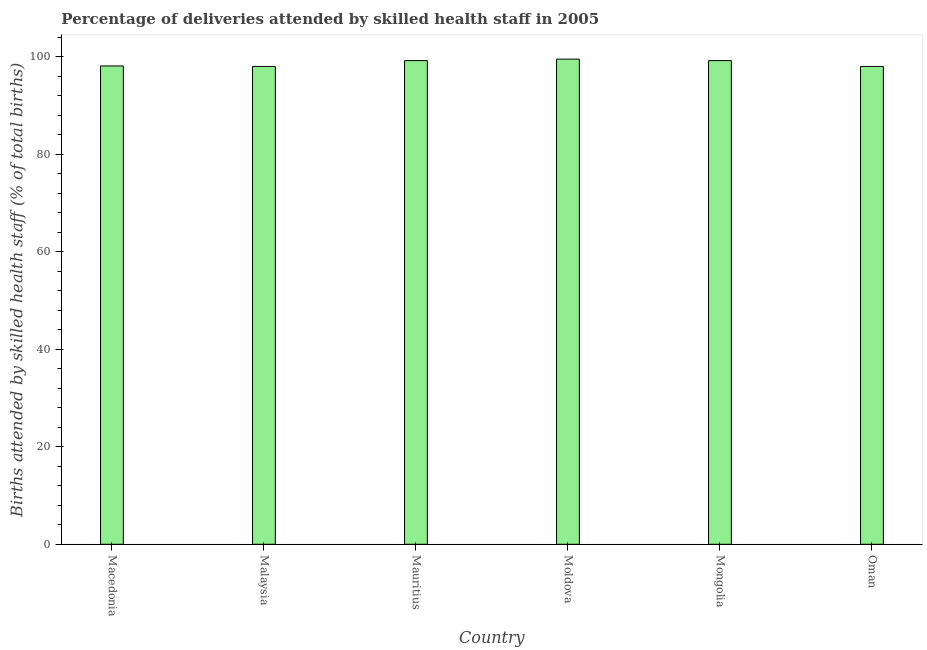Does the graph contain grids?
Offer a terse response. No. What is the title of the graph?
Keep it short and to the point. Percentage of deliveries attended by skilled health staff in 2005. What is the label or title of the X-axis?
Your answer should be compact. Country. What is the label or title of the Y-axis?
Provide a short and direct response. Births attended by skilled health staff (% of total births). What is the number of births attended by skilled health staff in Malaysia?
Give a very brief answer. 98. Across all countries, what is the maximum number of births attended by skilled health staff?
Make the answer very short. 99.5. Across all countries, what is the minimum number of births attended by skilled health staff?
Ensure brevity in your answer.  98. In which country was the number of births attended by skilled health staff maximum?
Give a very brief answer. Moldova. In which country was the number of births attended by skilled health staff minimum?
Keep it short and to the point. Malaysia. What is the sum of the number of births attended by skilled health staff?
Provide a succinct answer. 592. What is the average number of births attended by skilled health staff per country?
Provide a short and direct response. 98.67. What is the median number of births attended by skilled health staff?
Give a very brief answer. 98.65. In how many countries, is the number of births attended by skilled health staff greater than 72 %?
Make the answer very short. 6. What is the ratio of the number of births attended by skilled health staff in Mauritius to that in Oman?
Make the answer very short. 1.01. Is the number of births attended by skilled health staff in Macedonia less than that in Malaysia?
Give a very brief answer. No. Is the difference between the number of births attended by skilled health staff in Malaysia and Oman greater than the difference between any two countries?
Offer a terse response. No. Is the sum of the number of births attended by skilled health staff in Mauritius and Oman greater than the maximum number of births attended by skilled health staff across all countries?
Keep it short and to the point. Yes. What is the difference between the highest and the lowest number of births attended by skilled health staff?
Provide a succinct answer. 1.5. In how many countries, is the number of births attended by skilled health staff greater than the average number of births attended by skilled health staff taken over all countries?
Offer a very short reply. 3. How many bars are there?
Give a very brief answer. 6. How many countries are there in the graph?
Give a very brief answer. 6. What is the Births attended by skilled health staff (% of total births) in Macedonia?
Provide a short and direct response. 98.1. What is the Births attended by skilled health staff (% of total births) in Malaysia?
Offer a very short reply. 98. What is the Births attended by skilled health staff (% of total births) of Mauritius?
Give a very brief answer. 99.2. What is the Births attended by skilled health staff (% of total births) in Moldova?
Provide a succinct answer. 99.5. What is the Births attended by skilled health staff (% of total births) of Mongolia?
Provide a succinct answer. 99.2. What is the Births attended by skilled health staff (% of total births) in Oman?
Your answer should be compact. 98. What is the difference between the Births attended by skilled health staff (% of total births) in Macedonia and Moldova?
Your answer should be very brief. -1.4. What is the difference between the Births attended by skilled health staff (% of total births) in Macedonia and Oman?
Your answer should be compact. 0.1. What is the difference between the Births attended by skilled health staff (% of total births) in Mauritius and Moldova?
Keep it short and to the point. -0.3. What is the difference between the Births attended by skilled health staff (% of total births) in Moldova and Oman?
Provide a succinct answer. 1.5. What is the ratio of the Births attended by skilled health staff (% of total births) in Macedonia to that in Malaysia?
Provide a succinct answer. 1. What is the ratio of the Births attended by skilled health staff (% of total births) in Macedonia to that in Moldova?
Your answer should be very brief. 0.99. What is the ratio of the Births attended by skilled health staff (% of total births) in Macedonia to that in Mongolia?
Offer a terse response. 0.99. What is the ratio of the Births attended by skilled health staff (% of total births) in Malaysia to that in Mauritius?
Make the answer very short. 0.99. What is the ratio of the Births attended by skilled health staff (% of total births) in Malaysia to that in Oman?
Your answer should be compact. 1. What is the ratio of the Births attended by skilled health staff (% of total births) in Mauritius to that in Mongolia?
Your response must be concise. 1. 